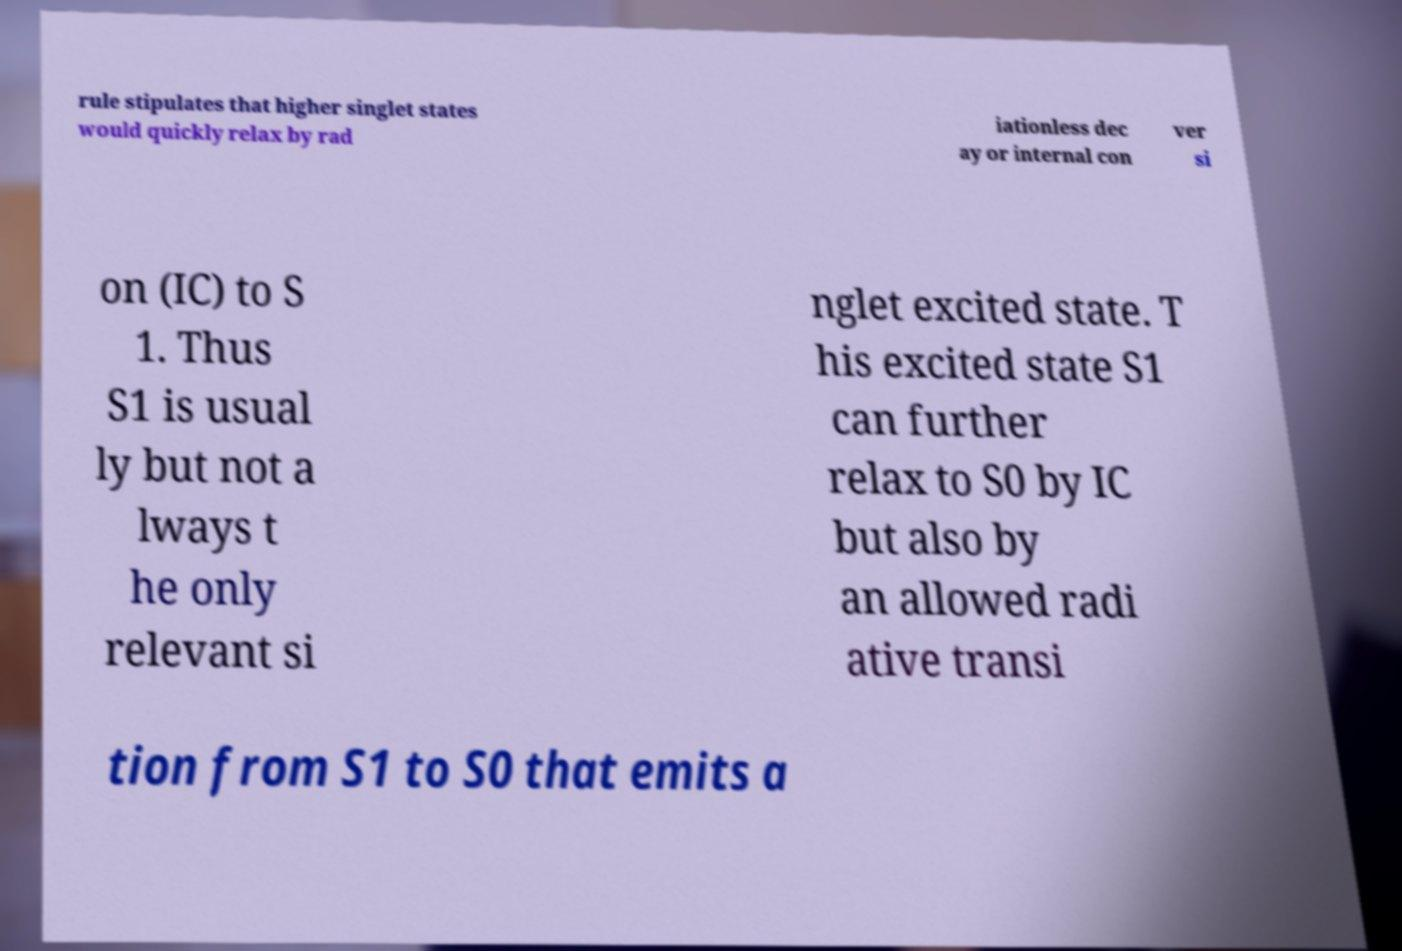Can you read and provide the text displayed in the image?This photo seems to have some interesting text. Can you extract and type it out for me? rule stipulates that higher singlet states would quickly relax by rad iationless dec ay or internal con ver si on (IC) to S 1. Thus S1 is usual ly but not a lways t he only relevant si nglet excited state. T his excited state S1 can further relax to S0 by IC but also by an allowed radi ative transi tion from S1 to S0 that emits a 